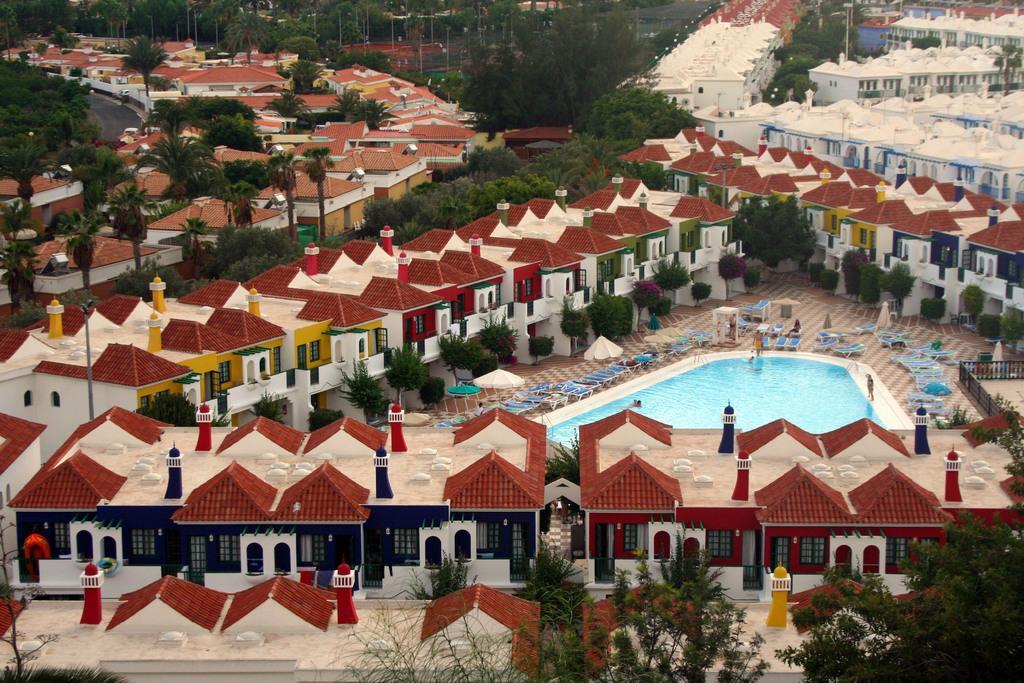Describe this image in one or two sentences. In this image we can see many buildings and trees. In the center there is a swimming pool and we can see parasols and chairs. 